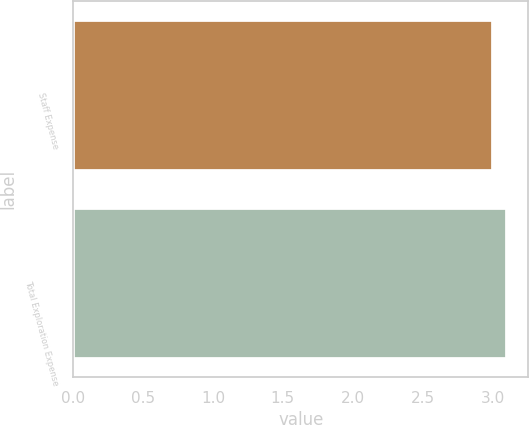Convert chart to OTSL. <chart><loc_0><loc_0><loc_500><loc_500><bar_chart><fcel>Staff Expense<fcel>Total Exploration Expense<nl><fcel>3<fcel>3.1<nl></chart> 